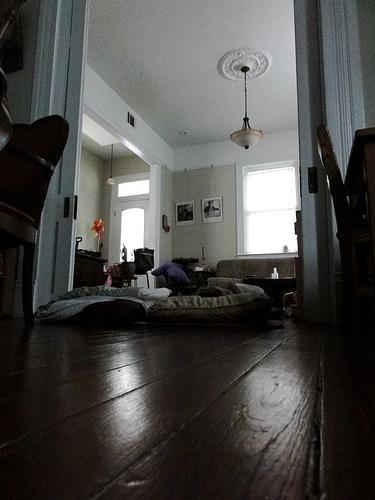How many lights are there?
Give a very brief answer. 1. 